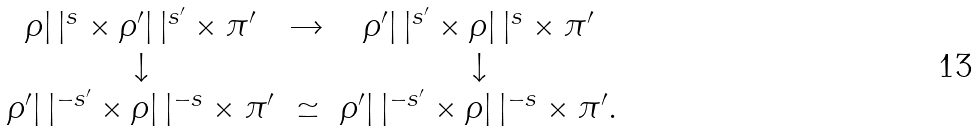Convert formula to latex. <formula><loc_0><loc_0><loc_500><loc_500>\begin{matrix} \rho | \, | ^ { s } \times \rho ^ { \prime } | \, | ^ { s ^ { \prime } } \times \pi ^ { \prime } & \rightarrow & \rho ^ { \prime } | \, | ^ { s ^ { \prime } } \times \rho | \, | ^ { s } \times \pi ^ { \prime } \\ \downarrow & & \downarrow \\ \rho ^ { \prime } | \, | ^ { - s ^ { \prime } } \times \rho | \, | ^ { - s } \times \pi ^ { \prime } & \simeq & \rho ^ { \prime } | \, | ^ { - s ^ { \prime } } \times \rho | \, | ^ { - s } \times \pi ^ { \prime } . \end{matrix}</formula> 